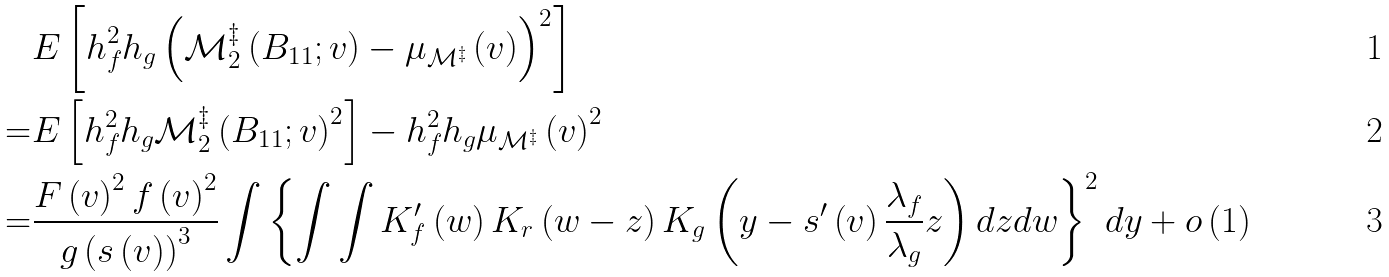<formula> <loc_0><loc_0><loc_500><loc_500>& E \left [ h _ { f } ^ { 2 } h _ { g } \left ( \mathcal { M } _ { 2 } ^ { \ddagger } \left ( B _ { 1 1 } ; v \right ) - \mu _ { \mathcal { M } ^ { \ddagger } } \left ( v \right ) \right ) ^ { 2 } \right ] \\ = & E \left [ h _ { f } ^ { 2 } h _ { g } \mathcal { M } _ { 2 } ^ { \ddagger } \left ( B _ { 1 1 } ; v \right ) ^ { 2 } \right ] - h _ { f } ^ { 2 } h _ { g } \mu _ { \mathcal { M } ^ { \ddagger } } \left ( v \right ) ^ { 2 } \\ = & \frac { F \left ( v \right ) ^ { 2 } f \left ( v \right ) ^ { 2 } } { g \left ( s \left ( v \right ) \right ) ^ { 3 } } \int \left \{ \int \int K _ { f } ^ { \prime } \left ( w \right ) K _ { r } \left ( w - z \right ) K _ { g } \left ( y - s ^ { \prime } \left ( v \right ) \frac { \lambda _ { f } } { \lambda _ { g } } z \right ) d z d w \right \} ^ { 2 } d y + o \left ( 1 \right )</formula> 